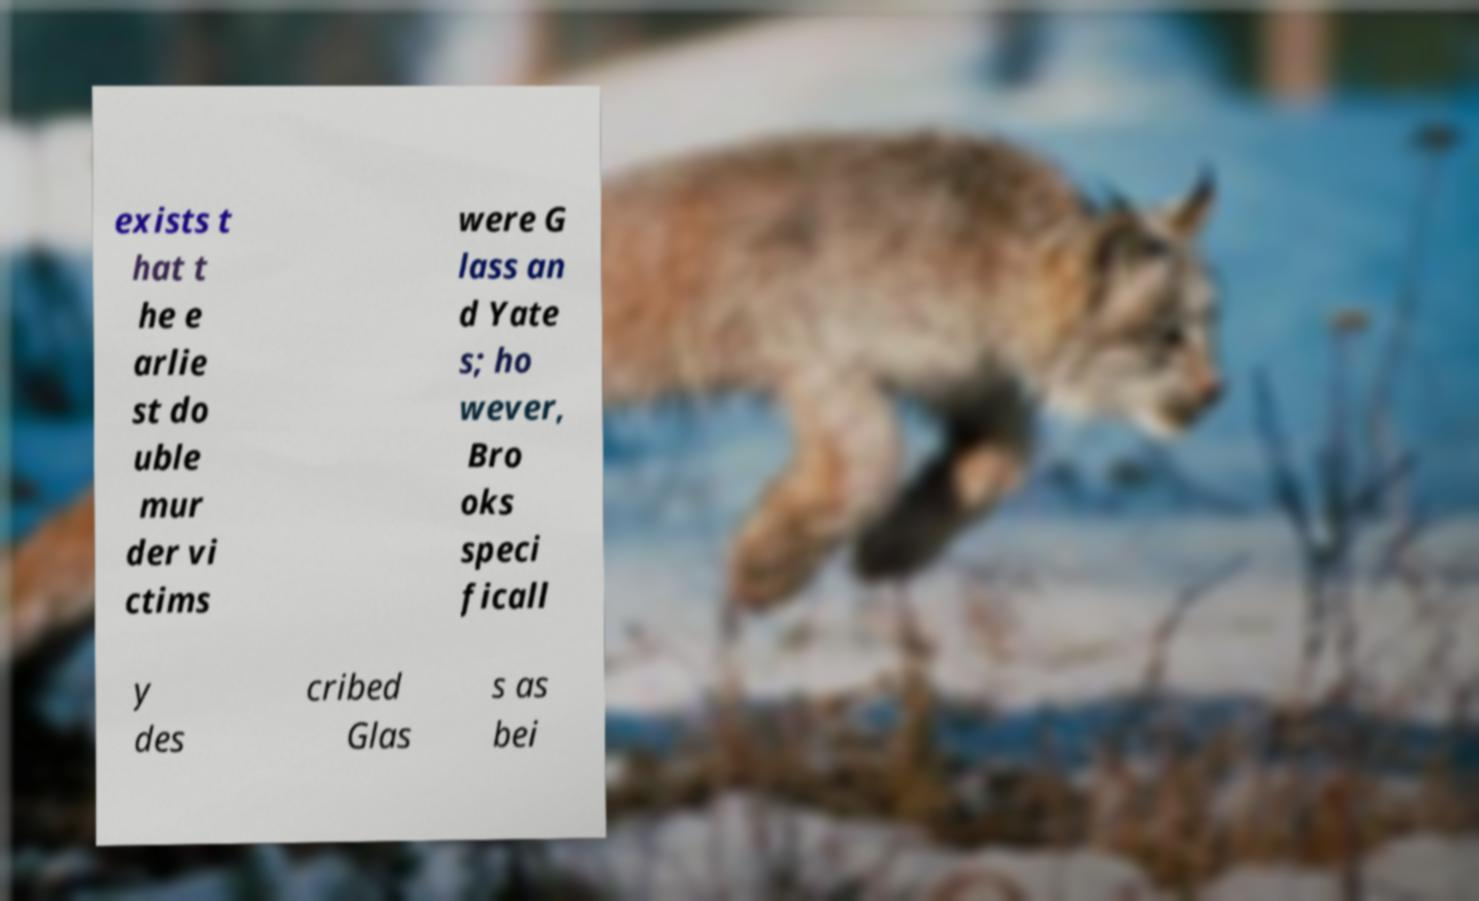I need the written content from this picture converted into text. Can you do that? exists t hat t he e arlie st do uble mur der vi ctims were G lass an d Yate s; ho wever, Bro oks speci ficall y des cribed Glas s as bei 